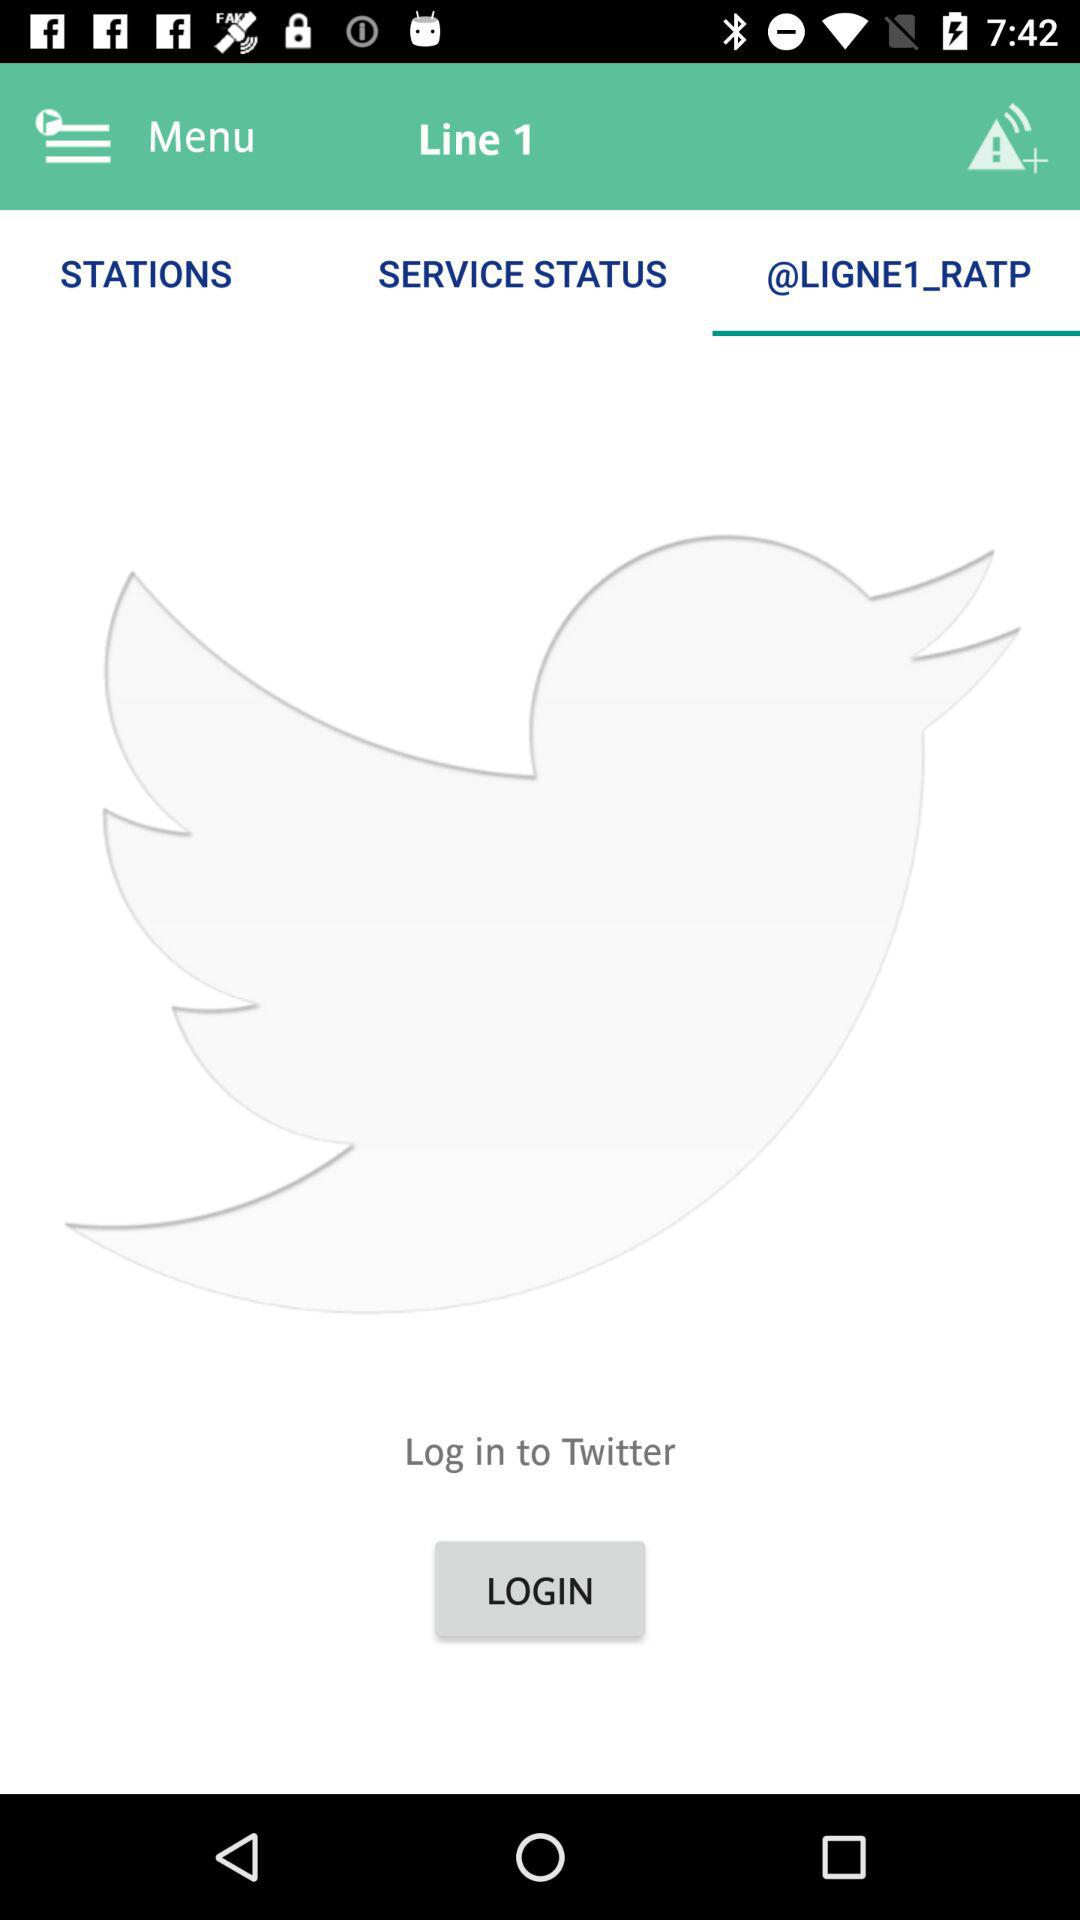What account can I use to log in? The account that can be used to log in is Twitter. 